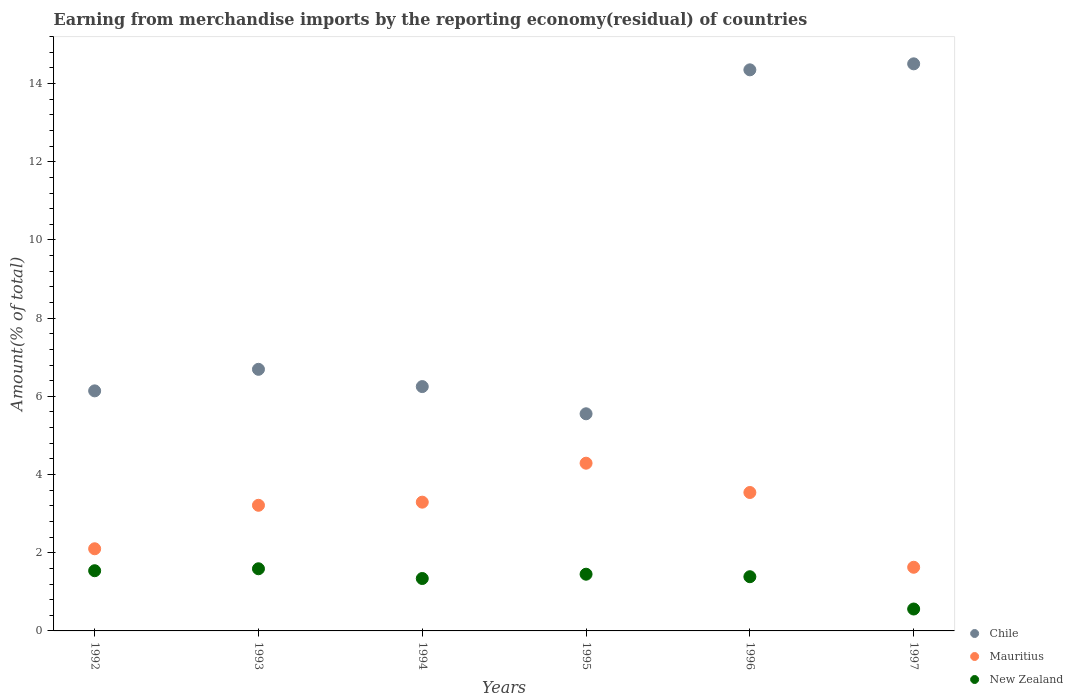How many different coloured dotlines are there?
Offer a very short reply. 3. Is the number of dotlines equal to the number of legend labels?
Provide a succinct answer. Yes. What is the percentage of amount earned from merchandise imports in Mauritius in 1993?
Your answer should be compact. 3.21. Across all years, what is the maximum percentage of amount earned from merchandise imports in Mauritius?
Provide a succinct answer. 4.29. Across all years, what is the minimum percentage of amount earned from merchandise imports in Mauritius?
Ensure brevity in your answer.  1.63. In which year was the percentage of amount earned from merchandise imports in Mauritius minimum?
Provide a short and direct response. 1997. What is the total percentage of amount earned from merchandise imports in New Zealand in the graph?
Your answer should be compact. 7.87. What is the difference between the percentage of amount earned from merchandise imports in Mauritius in 1993 and that in 1996?
Keep it short and to the point. -0.33. What is the difference between the percentage of amount earned from merchandise imports in Mauritius in 1992 and the percentage of amount earned from merchandise imports in Chile in 1996?
Ensure brevity in your answer.  -12.25. What is the average percentage of amount earned from merchandise imports in Mauritius per year?
Give a very brief answer. 3.01. In the year 1996, what is the difference between the percentage of amount earned from merchandise imports in Chile and percentage of amount earned from merchandise imports in Mauritius?
Provide a succinct answer. 10.81. In how many years, is the percentage of amount earned from merchandise imports in New Zealand greater than 14.8 %?
Provide a short and direct response. 0. What is the ratio of the percentage of amount earned from merchandise imports in Mauritius in 1992 to that in 1996?
Offer a very short reply. 0.59. Is the percentage of amount earned from merchandise imports in Mauritius in 1994 less than that in 1995?
Make the answer very short. Yes. Is the difference between the percentage of amount earned from merchandise imports in Chile in 1992 and 1994 greater than the difference between the percentage of amount earned from merchandise imports in Mauritius in 1992 and 1994?
Your answer should be very brief. Yes. What is the difference between the highest and the second highest percentage of amount earned from merchandise imports in Mauritius?
Provide a short and direct response. 0.75. What is the difference between the highest and the lowest percentage of amount earned from merchandise imports in New Zealand?
Provide a succinct answer. 1.03. Is the percentage of amount earned from merchandise imports in Mauritius strictly greater than the percentage of amount earned from merchandise imports in Chile over the years?
Make the answer very short. No. Is the percentage of amount earned from merchandise imports in Chile strictly less than the percentage of amount earned from merchandise imports in Mauritius over the years?
Keep it short and to the point. No. Are the values on the major ticks of Y-axis written in scientific E-notation?
Offer a very short reply. No. What is the title of the graph?
Your answer should be very brief. Earning from merchandise imports by the reporting economy(residual) of countries. What is the label or title of the X-axis?
Provide a short and direct response. Years. What is the label or title of the Y-axis?
Provide a short and direct response. Amount(% of total). What is the Amount(% of total) of Chile in 1992?
Give a very brief answer. 6.14. What is the Amount(% of total) of Mauritius in 1992?
Offer a terse response. 2.1. What is the Amount(% of total) in New Zealand in 1992?
Provide a succinct answer. 1.54. What is the Amount(% of total) in Chile in 1993?
Offer a very short reply. 6.69. What is the Amount(% of total) of Mauritius in 1993?
Make the answer very short. 3.21. What is the Amount(% of total) in New Zealand in 1993?
Provide a succinct answer. 1.59. What is the Amount(% of total) of Chile in 1994?
Keep it short and to the point. 6.25. What is the Amount(% of total) in Mauritius in 1994?
Provide a succinct answer. 3.29. What is the Amount(% of total) in New Zealand in 1994?
Provide a short and direct response. 1.34. What is the Amount(% of total) of Chile in 1995?
Provide a short and direct response. 5.55. What is the Amount(% of total) of Mauritius in 1995?
Keep it short and to the point. 4.29. What is the Amount(% of total) in New Zealand in 1995?
Offer a terse response. 1.45. What is the Amount(% of total) of Chile in 1996?
Ensure brevity in your answer.  14.35. What is the Amount(% of total) in Mauritius in 1996?
Offer a very short reply. 3.54. What is the Amount(% of total) in New Zealand in 1996?
Offer a terse response. 1.39. What is the Amount(% of total) of Chile in 1997?
Your answer should be very brief. 14.5. What is the Amount(% of total) of Mauritius in 1997?
Your answer should be compact. 1.63. What is the Amount(% of total) of New Zealand in 1997?
Offer a very short reply. 0.56. Across all years, what is the maximum Amount(% of total) of Chile?
Keep it short and to the point. 14.5. Across all years, what is the maximum Amount(% of total) of Mauritius?
Your response must be concise. 4.29. Across all years, what is the maximum Amount(% of total) in New Zealand?
Give a very brief answer. 1.59. Across all years, what is the minimum Amount(% of total) of Chile?
Your answer should be very brief. 5.55. Across all years, what is the minimum Amount(% of total) of Mauritius?
Your answer should be compact. 1.63. Across all years, what is the minimum Amount(% of total) of New Zealand?
Keep it short and to the point. 0.56. What is the total Amount(% of total) of Chile in the graph?
Provide a short and direct response. 53.49. What is the total Amount(% of total) in Mauritius in the graph?
Your answer should be very brief. 18.07. What is the total Amount(% of total) in New Zealand in the graph?
Offer a very short reply. 7.87. What is the difference between the Amount(% of total) in Chile in 1992 and that in 1993?
Offer a very short reply. -0.55. What is the difference between the Amount(% of total) of Mauritius in 1992 and that in 1993?
Make the answer very short. -1.11. What is the difference between the Amount(% of total) of New Zealand in 1992 and that in 1993?
Your response must be concise. -0.05. What is the difference between the Amount(% of total) in Chile in 1992 and that in 1994?
Your response must be concise. -0.11. What is the difference between the Amount(% of total) of Mauritius in 1992 and that in 1994?
Provide a succinct answer. -1.19. What is the difference between the Amount(% of total) in New Zealand in 1992 and that in 1994?
Ensure brevity in your answer.  0.2. What is the difference between the Amount(% of total) of Chile in 1992 and that in 1995?
Offer a terse response. 0.59. What is the difference between the Amount(% of total) of Mauritius in 1992 and that in 1995?
Ensure brevity in your answer.  -2.19. What is the difference between the Amount(% of total) of New Zealand in 1992 and that in 1995?
Your answer should be compact. 0.09. What is the difference between the Amount(% of total) of Chile in 1992 and that in 1996?
Give a very brief answer. -8.21. What is the difference between the Amount(% of total) of Mauritius in 1992 and that in 1996?
Give a very brief answer. -1.44. What is the difference between the Amount(% of total) of New Zealand in 1992 and that in 1996?
Provide a succinct answer. 0.15. What is the difference between the Amount(% of total) in Chile in 1992 and that in 1997?
Give a very brief answer. -8.36. What is the difference between the Amount(% of total) of Mauritius in 1992 and that in 1997?
Your answer should be very brief. 0.47. What is the difference between the Amount(% of total) in New Zealand in 1992 and that in 1997?
Make the answer very short. 0.98. What is the difference between the Amount(% of total) of Chile in 1993 and that in 1994?
Your response must be concise. 0.44. What is the difference between the Amount(% of total) in Mauritius in 1993 and that in 1994?
Your response must be concise. -0.08. What is the difference between the Amount(% of total) of New Zealand in 1993 and that in 1994?
Keep it short and to the point. 0.25. What is the difference between the Amount(% of total) in Chile in 1993 and that in 1995?
Provide a succinct answer. 1.14. What is the difference between the Amount(% of total) in Mauritius in 1993 and that in 1995?
Ensure brevity in your answer.  -1.08. What is the difference between the Amount(% of total) in New Zealand in 1993 and that in 1995?
Ensure brevity in your answer.  0.14. What is the difference between the Amount(% of total) in Chile in 1993 and that in 1996?
Provide a succinct answer. -7.66. What is the difference between the Amount(% of total) in Mauritius in 1993 and that in 1996?
Ensure brevity in your answer.  -0.33. What is the difference between the Amount(% of total) of New Zealand in 1993 and that in 1996?
Provide a short and direct response. 0.2. What is the difference between the Amount(% of total) of Chile in 1993 and that in 1997?
Keep it short and to the point. -7.81. What is the difference between the Amount(% of total) in Mauritius in 1993 and that in 1997?
Ensure brevity in your answer.  1.59. What is the difference between the Amount(% of total) in New Zealand in 1993 and that in 1997?
Give a very brief answer. 1.03. What is the difference between the Amount(% of total) of Chile in 1994 and that in 1995?
Offer a very short reply. 0.7. What is the difference between the Amount(% of total) of Mauritius in 1994 and that in 1995?
Provide a succinct answer. -1. What is the difference between the Amount(% of total) of New Zealand in 1994 and that in 1995?
Provide a short and direct response. -0.11. What is the difference between the Amount(% of total) of Chile in 1994 and that in 1996?
Provide a succinct answer. -8.1. What is the difference between the Amount(% of total) in Mauritius in 1994 and that in 1996?
Offer a terse response. -0.25. What is the difference between the Amount(% of total) of New Zealand in 1994 and that in 1996?
Provide a succinct answer. -0.05. What is the difference between the Amount(% of total) of Chile in 1994 and that in 1997?
Make the answer very short. -8.25. What is the difference between the Amount(% of total) in Mauritius in 1994 and that in 1997?
Provide a succinct answer. 1.66. What is the difference between the Amount(% of total) in New Zealand in 1994 and that in 1997?
Your response must be concise. 0.78. What is the difference between the Amount(% of total) of Chile in 1995 and that in 1996?
Make the answer very short. -8.8. What is the difference between the Amount(% of total) of Mauritius in 1995 and that in 1996?
Ensure brevity in your answer.  0.75. What is the difference between the Amount(% of total) of New Zealand in 1995 and that in 1996?
Make the answer very short. 0.06. What is the difference between the Amount(% of total) in Chile in 1995 and that in 1997?
Provide a succinct answer. -8.95. What is the difference between the Amount(% of total) in Mauritius in 1995 and that in 1997?
Offer a very short reply. 2.66. What is the difference between the Amount(% of total) of New Zealand in 1995 and that in 1997?
Provide a short and direct response. 0.89. What is the difference between the Amount(% of total) in Chile in 1996 and that in 1997?
Offer a very short reply. -0.15. What is the difference between the Amount(% of total) in Mauritius in 1996 and that in 1997?
Offer a very short reply. 1.91. What is the difference between the Amount(% of total) of New Zealand in 1996 and that in 1997?
Provide a succinct answer. 0.83. What is the difference between the Amount(% of total) of Chile in 1992 and the Amount(% of total) of Mauritius in 1993?
Keep it short and to the point. 2.93. What is the difference between the Amount(% of total) of Chile in 1992 and the Amount(% of total) of New Zealand in 1993?
Give a very brief answer. 4.55. What is the difference between the Amount(% of total) of Mauritius in 1992 and the Amount(% of total) of New Zealand in 1993?
Provide a succinct answer. 0.51. What is the difference between the Amount(% of total) in Chile in 1992 and the Amount(% of total) in Mauritius in 1994?
Your response must be concise. 2.85. What is the difference between the Amount(% of total) in Chile in 1992 and the Amount(% of total) in New Zealand in 1994?
Offer a terse response. 4.8. What is the difference between the Amount(% of total) in Mauritius in 1992 and the Amount(% of total) in New Zealand in 1994?
Provide a short and direct response. 0.76. What is the difference between the Amount(% of total) of Chile in 1992 and the Amount(% of total) of Mauritius in 1995?
Keep it short and to the point. 1.85. What is the difference between the Amount(% of total) of Chile in 1992 and the Amount(% of total) of New Zealand in 1995?
Your answer should be compact. 4.69. What is the difference between the Amount(% of total) of Mauritius in 1992 and the Amount(% of total) of New Zealand in 1995?
Offer a terse response. 0.65. What is the difference between the Amount(% of total) of Chile in 1992 and the Amount(% of total) of Mauritius in 1996?
Keep it short and to the point. 2.6. What is the difference between the Amount(% of total) in Chile in 1992 and the Amount(% of total) in New Zealand in 1996?
Offer a very short reply. 4.75. What is the difference between the Amount(% of total) of Mauritius in 1992 and the Amount(% of total) of New Zealand in 1996?
Provide a short and direct response. 0.71. What is the difference between the Amount(% of total) of Chile in 1992 and the Amount(% of total) of Mauritius in 1997?
Your answer should be very brief. 4.51. What is the difference between the Amount(% of total) in Chile in 1992 and the Amount(% of total) in New Zealand in 1997?
Your response must be concise. 5.58. What is the difference between the Amount(% of total) of Mauritius in 1992 and the Amount(% of total) of New Zealand in 1997?
Make the answer very short. 1.54. What is the difference between the Amount(% of total) of Chile in 1993 and the Amount(% of total) of Mauritius in 1994?
Your response must be concise. 3.4. What is the difference between the Amount(% of total) in Chile in 1993 and the Amount(% of total) in New Zealand in 1994?
Provide a short and direct response. 5.35. What is the difference between the Amount(% of total) of Mauritius in 1993 and the Amount(% of total) of New Zealand in 1994?
Offer a terse response. 1.87. What is the difference between the Amount(% of total) in Chile in 1993 and the Amount(% of total) in Mauritius in 1995?
Your answer should be very brief. 2.4. What is the difference between the Amount(% of total) in Chile in 1993 and the Amount(% of total) in New Zealand in 1995?
Your answer should be compact. 5.24. What is the difference between the Amount(% of total) of Mauritius in 1993 and the Amount(% of total) of New Zealand in 1995?
Provide a short and direct response. 1.76. What is the difference between the Amount(% of total) in Chile in 1993 and the Amount(% of total) in Mauritius in 1996?
Provide a succinct answer. 3.15. What is the difference between the Amount(% of total) of Chile in 1993 and the Amount(% of total) of New Zealand in 1996?
Provide a succinct answer. 5.3. What is the difference between the Amount(% of total) in Mauritius in 1993 and the Amount(% of total) in New Zealand in 1996?
Ensure brevity in your answer.  1.83. What is the difference between the Amount(% of total) of Chile in 1993 and the Amount(% of total) of Mauritius in 1997?
Make the answer very short. 5.06. What is the difference between the Amount(% of total) in Chile in 1993 and the Amount(% of total) in New Zealand in 1997?
Your answer should be very brief. 6.13. What is the difference between the Amount(% of total) of Mauritius in 1993 and the Amount(% of total) of New Zealand in 1997?
Keep it short and to the point. 2.65. What is the difference between the Amount(% of total) in Chile in 1994 and the Amount(% of total) in Mauritius in 1995?
Offer a terse response. 1.96. What is the difference between the Amount(% of total) in Chile in 1994 and the Amount(% of total) in New Zealand in 1995?
Make the answer very short. 4.8. What is the difference between the Amount(% of total) in Mauritius in 1994 and the Amount(% of total) in New Zealand in 1995?
Offer a terse response. 1.84. What is the difference between the Amount(% of total) in Chile in 1994 and the Amount(% of total) in Mauritius in 1996?
Give a very brief answer. 2.71. What is the difference between the Amount(% of total) in Chile in 1994 and the Amount(% of total) in New Zealand in 1996?
Provide a succinct answer. 4.86. What is the difference between the Amount(% of total) in Mauritius in 1994 and the Amount(% of total) in New Zealand in 1996?
Your answer should be very brief. 1.91. What is the difference between the Amount(% of total) in Chile in 1994 and the Amount(% of total) in Mauritius in 1997?
Your response must be concise. 4.62. What is the difference between the Amount(% of total) in Chile in 1994 and the Amount(% of total) in New Zealand in 1997?
Keep it short and to the point. 5.69. What is the difference between the Amount(% of total) of Mauritius in 1994 and the Amount(% of total) of New Zealand in 1997?
Your response must be concise. 2.73. What is the difference between the Amount(% of total) of Chile in 1995 and the Amount(% of total) of Mauritius in 1996?
Your answer should be very brief. 2.01. What is the difference between the Amount(% of total) of Chile in 1995 and the Amount(% of total) of New Zealand in 1996?
Provide a short and direct response. 4.17. What is the difference between the Amount(% of total) in Mauritius in 1995 and the Amount(% of total) in New Zealand in 1996?
Make the answer very short. 2.9. What is the difference between the Amount(% of total) of Chile in 1995 and the Amount(% of total) of Mauritius in 1997?
Offer a very short reply. 3.93. What is the difference between the Amount(% of total) of Chile in 1995 and the Amount(% of total) of New Zealand in 1997?
Offer a terse response. 4.99. What is the difference between the Amount(% of total) of Mauritius in 1995 and the Amount(% of total) of New Zealand in 1997?
Ensure brevity in your answer.  3.73. What is the difference between the Amount(% of total) of Chile in 1996 and the Amount(% of total) of Mauritius in 1997?
Keep it short and to the point. 12.72. What is the difference between the Amount(% of total) in Chile in 1996 and the Amount(% of total) in New Zealand in 1997?
Offer a very short reply. 13.79. What is the difference between the Amount(% of total) in Mauritius in 1996 and the Amount(% of total) in New Zealand in 1997?
Offer a terse response. 2.98. What is the average Amount(% of total) in Chile per year?
Your answer should be very brief. 8.91. What is the average Amount(% of total) of Mauritius per year?
Your answer should be compact. 3.01. What is the average Amount(% of total) in New Zealand per year?
Your answer should be very brief. 1.31. In the year 1992, what is the difference between the Amount(% of total) in Chile and Amount(% of total) in Mauritius?
Offer a terse response. 4.04. In the year 1992, what is the difference between the Amount(% of total) of Chile and Amount(% of total) of New Zealand?
Make the answer very short. 4.6. In the year 1992, what is the difference between the Amount(% of total) in Mauritius and Amount(% of total) in New Zealand?
Provide a succinct answer. 0.56. In the year 1993, what is the difference between the Amount(% of total) in Chile and Amount(% of total) in Mauritius?
Give a very brief answer. 3.48. In the year 1993, what is the difference between the Amount(% of total) in Chile and Amount(% of total) in New Zealand?
Offer a very short reply. 5.1. In the year 1993, what is the difference between the Amount(% of total) of Mauritius and Amount(% of total) of New Zealand?
Your answer should be very brief. 1.62. In the year 1994, what is the difference between the Amount(% of total) in Chile and Amount(% of total) in Mauritius?
Your response must be concise. 2.96. In the year 1994, what is the difference between the Amount(% of total) of Chile and Amount(% of total) of New Zealand?
Provide a short and direct response. 4.91. In the year 1994, what is the difference between the Amount(% of total) in Mauritius and Amount(% of total) in New Zealand?
Your answer should be very brief. 1.95. In the year 1995, what is the difference between the Amount(% of total) of Chile and Amount(% of total) of Mauritius?
Your answer should be very brief. 1.26. In the year 1995, what is the difference between the Amount(% of total) of Chile and Amount(% of total) of New Zealand?
Your answer should be very brief. 4.1. In the year 1995, what is the difference between the Amount(% of total) of Mauritius and Amount(% of total) of New Zealand?
Offer a very short reply. 2.84. In the year 1996, what is the difference between the Amount(% of total) of Chile and Amount(% of total) of Mauritius?
Give a very brief answer. 10.81. In the year 1996, what is the difference between the Amount(% of total) in Chile and Amount(% of total) in New Zealand?
Your answer should be very brief. 12.96. In the year 1996, what is the difference between the Amount(% of total) of Mauritius and Amount(% of total) of New Zealand?
Your answer should be compact. 2.15. In the year 1997, what is the difference between the Amount(% of total) of Chile and Amount(% of total) of Mauritius?
Your response must be concise. 12.88. In the year 1997, what is the difference between the Amount(% of total) of Chile and Amount(% of total) of New Zealand?
Your response must be concise. 13.94. In the year 1997, what is the difference between the Amount(% of total) of Mauritius and Amount(% of total) of New Zealand?
Offer a very short reply. 1.07. What is the ratio of the Amount(% of total) of Chile in 1992 to that in 1993?
Keep it short and to the point. 0.92. What is the ratio of the Amount(% of total) of Mauritius in 1992 to that in 1993?
Ensure brevity in your answer.  0.65. What is the ratio of the Amount(% of total) in New Zealand in 1992 to that in 1993?
Offer a very short reply. 0.97. What is the ratio of the Amount(% of total) of Chile in 1992 to that in 1994?
Your answer should be very brief. 0.98. What is the ratio of the Amount(% of total) in Mauritius in 1992 to that in 1994?
Your response must be concise. 0.64. What is the ratio of the Amount(% of total) in New Zealand in 1992 to that in 1994?
Provide a succinct answer. 1.15. What is the ratio of the Amount(% of total) in Chile in 1992 to that in 1995?
Offer a terse response. 1.11. What is the ratio of the Amount(% of total) in Mauritius in 1992 to that in 1995?
Your response must be concise. 0.49. What is the ratio of the Amount(% of total) of New Zealand in 1992 to that in 1995?
Make the answer very short. 1.06. What is the ratio of the Amount(% of total) in Chile in 1992 to that in 1996?
Offer a very short reply. 0.43. What is the ratio of the Amount(% of total) of Mauritius in 1992 to that in 1996?
Your response must be concise. 0.59. What is the ratio of the Amount(% of total) in New Zealand in 1992 to that in 1996?
Give a very brief answer. 1.11. What is the ratio of the Amount(% of total) in Chile in 1992 to that in 1997?
Provide a succinct answer. 0.42. What is the ratio of the Amount(% of total) of Mauritius in 1992 to that in 1997?
Your answer should be compact. 1.29. What is the ratio of the Amount(% of total) of New Zealand in 1992 to that in 1997?
Offer a very short reply. 2.75. What is the ratio of the Amount(% of total) of Chile in 1993 to that in 1994?
Your answer should be compact. 1.07. What is the ratio of the Amount(% of total) of Mauritius in 1993 to that in 1994?
Offer a very short reply. 0.98. What is the ratio of the Amount(% of total) of New Zealand in 1993 to that in 1994?
Your answer should be compact. 1.19. What is the ratio of the Amount(% of total) of Chile in 1993 to that in 1995?
Provide a short and direct response. 1.2. What is the ratio of the Amount(% of total) in Mauritius in 1993 to that in 1995?
Provide a short and direct response. 0.75. What is the ratio of the Amount(% of total) of New Zealand in 1993 to that in 1995?
Offer a very short reply. 1.1. What is the ratio of the Amount(% of total) of Chile in 1993 to that in 1996?
Offer a very short reply. 0.47. What is the ratio of the Amount(% of total) of Mauritius in 1993 to that in 1996?
Keep it short and to the point. 0.91. What is the ratio of the Amount(% of total) of New Zealand in 1993 to that in 1996?
Provide a succinct answer. 1.15. What is the ratio of the Amount(% of total) of Chile in 1993 to that in 1997?
Provide a succinct answer. 0.46. What is the ratio of the Amount(% of total) of Mauritius in 1993 to that in 1997?
Provide a short and direct response. 1.97. What is the ratio of the Amount(% of total) in New Zealand in 1993 to that in 1997?
Offer a terse response. 2.84. What is the ratio of the Amount(% of total) in Chile in 1994 to that in 1995?
Your response must be concise. 1.13. What is the ratio of the Amount(% of total) in Mauritius in 1994 to that in 1995?
Give a very brief answer. 0.77. What is the ratio of the Amount(% of total) of New Zealand in 1994 to that in 1995?
Give a very brief answer. 0.92. What is the ratio of the Amount(% of total) of Chile in 1994 to that in 1996?
Your response must be concise. 0.44. What is the ratio of the Amount(% of total) of Mauritius in 1994 to that in 1996?
Keep it short and to the point. 0.93. What is the ratio of the Amount(% of total) in New Zealand in 1994 to that in 1996?
Your answer should be compact. 0.97. What is the ratio of the Amount(% of total) of Chile in 1994 to that in 1997?
Your response must be concise. 0.43. What is the ratio of the Amount(% of total) of Mauritius in 1994 to that in 1997?
Keep it short and to the point. 2.02. What is the ratio of the Amount(% of total) in New Zealand in 1994 to that in 1997?
Your answer should be very brief. 2.39. What is the ratio of the Amount(% of total) in Chile in 1995 to that in 1996?
Your answer should be very brief. 0.39. What is the ratio of the Amount(% of total) of Mauritius in 1995 to that in 1996?
Make the answer very short. 1.21. What is the ratio of the Amount(% of total) of New Zealand in 1995 to that in 1996?
Make the answer very short. 1.05. What is the ratio of the Amount(% of total) in Chile in 1995 to that in 1997?
Provide a succinct answer. 0.38. What is the ratio of the Amount(% of total) in Mauritius in 1995 to that in 1997?
Provide a short and direct response. 2.63. What is the ratio of the Amount(% of total) of New Zealand in 1995 to that in 1997?
Your answer should be very brief. 2.59. What is the ratio of the Amount(% of total) of Chile in 1996 to that in 1997?
Provide a succinct answer. 0.99. What is the ratio of the Amount(% of total) in Mauritius in 1996 to that in 1997?
Your response must be concise. 2.17. What is the ratio of the Amount(% of total) in New Zealand in 1996 to that in 1997?
Your answer should be compact. 2.47. What is the difference between the highest and the second highest Amount(% of total) in Chile?
Provide a succinct answer. 0.15. What is the difference between the highest and the second highest Amount(% of total) in Mauritius?
Provide a succinct answer. 0.75. What is the difference between the highest and the second highest Amount(% of total) in New Zealand?
Your response must be concise. 0.05. What is the difference between the highest and the lowest Amount(% of total) of Chile?
Offer a terse response. 8.95. What is the difference between the highest and the lowest Amount(% of total) of Mauritius?
Offer a very short reply. 2.66. What is the difference between the highest and the lowest Amount(% of total) of New Zealand?
Your answer should be very brief. 1.03. 